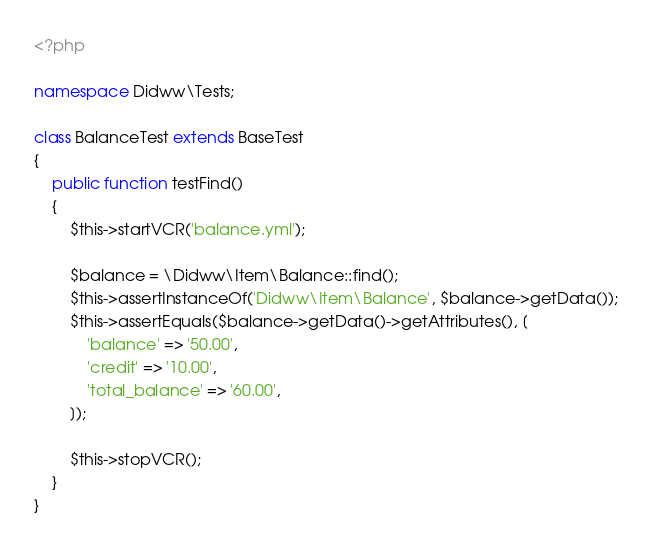Convert code to text. <code><loc_0><loc_0><loc_500><loc_500><_PHP_><?php

namespace Didww\Tests;

class BalanceTest extends BaseTest
{
    public function testFind()
    {
        $this->startVCR('balance.yml');

        $balance = \Didww\Item\Balance::find();
        $this->assertInstanceOf('Didww\Item\Balance', $balance->getData());
        $this->assertEquals($balance->getData()->getAttributes(), [
            'balance' => '50.00',
            'credit' => '10.00',
            'total_balance' => '60.00',
        ]);

        $this->stopVCR();
    }
}
</code> 